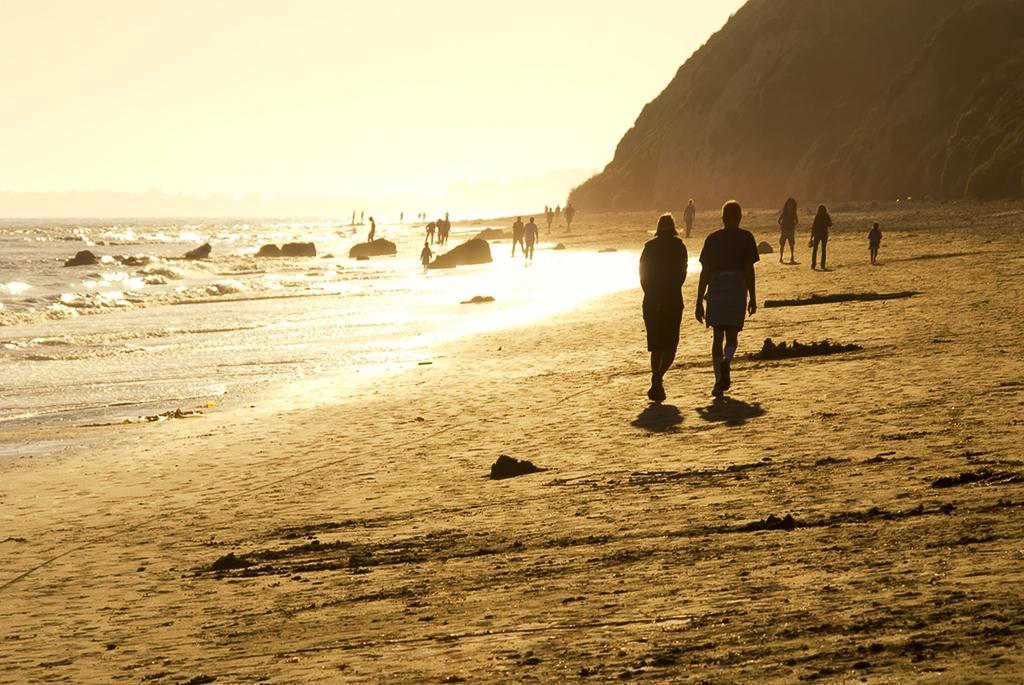In one or two sentences, can you explain what this image depicts? In this image there is the sky towards the top of the image, there is a mountain towards the right of the image, there is water towards the right of the image, there are a group of persons walking, there is sand towards the right of the image, there is sand towards the bottom of the image. 